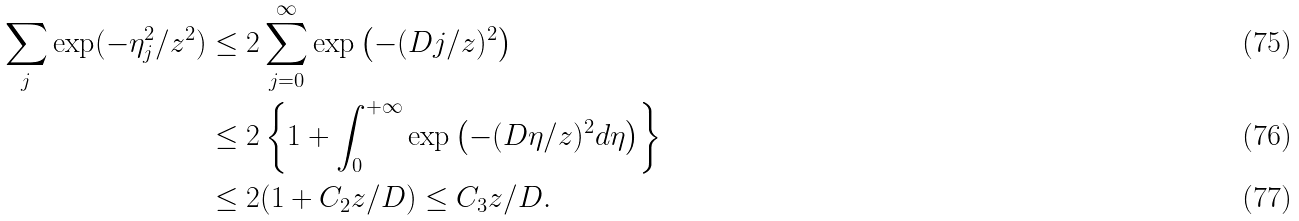<formula> <loc_0><loc_0><loc_500><loc_500>\sum _ { j } \exp ( - \eta _ { j } ^ { 2 } / z ^ { 2 } ) & \leq 2 \sum _ { j = 0 } ^ { \infty } \exp \left ( - ( D j / z ) ^ { 2 } \right ) \\ & \leq 2 \left \{ 1 + \int _ { 0 } ^ { + \infty } \exp \left ( - ( D \eta / z ) ^ { 2 } d \eta \right ) \right \} \\ & \leq 2 ( 1 + C _ { 2 } z / D ) \leq C _ { 3 } z / D .</formula> 